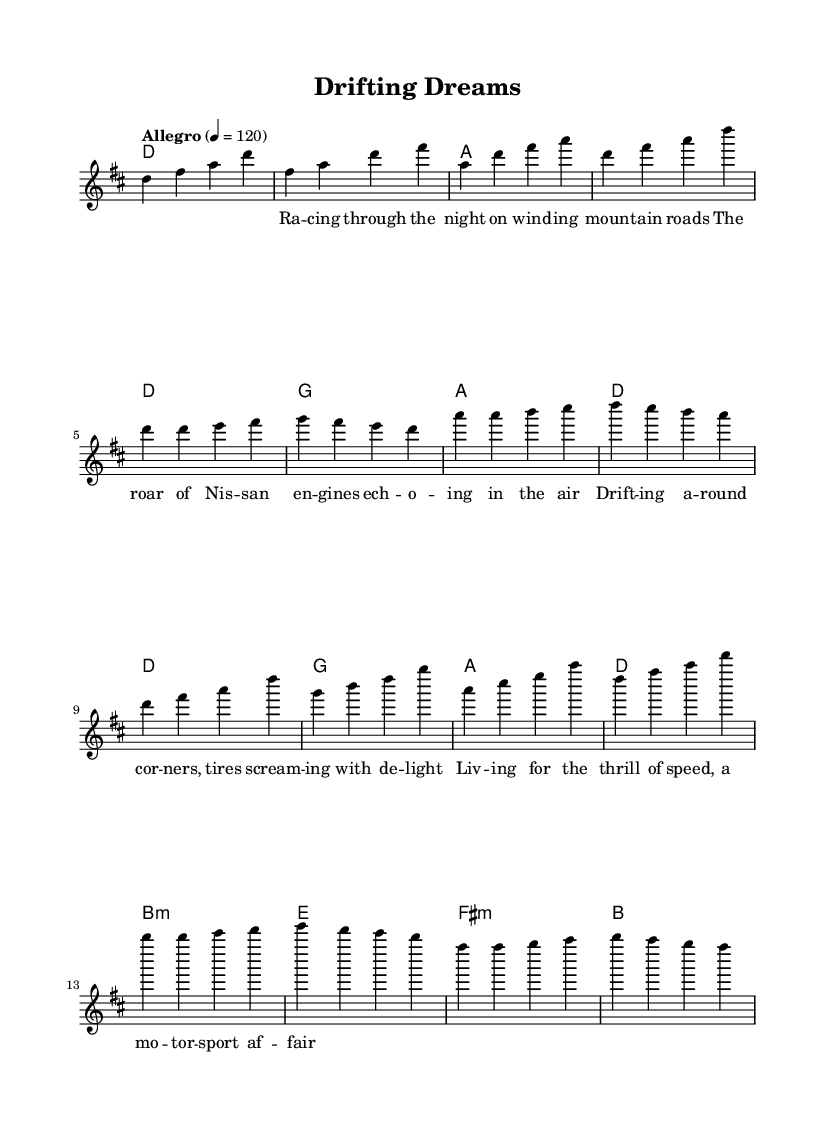What is the key signature of this music? The key signature is indicated at the beginning of the score. Here, the presence of two sharps (F# and C#) in the key signature indicates that the key is D major.
Answer: D major What is the time signature of this music? The time signature is found at the start of the score. It is written as 4/4, which means there are four beats in each measure and a quarter note receives one beat.
Answer: 4/4 What is the tempo marking of the piece? The tempo marking appears in the score, directly stating "Allegro" with a metronome marking of quarter note equals 120, indicating a fast tempo.
Answer: Allegro, 120 How many measures are in the chorus section? The chorus section can be identified in the score by counting the number of measures under the chorus lyrics. It consists of four measures.
Answer: 4 Which chord is played alongside the first bar of the verse? The first bar of the verse shows the chord above the staff. It indicates that the chord for the first bar is D major.
Answer: D Which line of the lyrics emphasizes the thrill of motorsport? In the lyrics section, the line that conveys the excitement of motorsport is “Living for the thrill of speed, a motorsport affair,” reflecting the theme of speed and excitement.
Answer: Living for the thrill of speed What is the primary theme reflected in the lyrics? The lyrics throughout the composition consistently depict themes related to racing and car enthusiasm, specifically focusing on drifting and the joy of driving.
Answer: Motorsport culture 